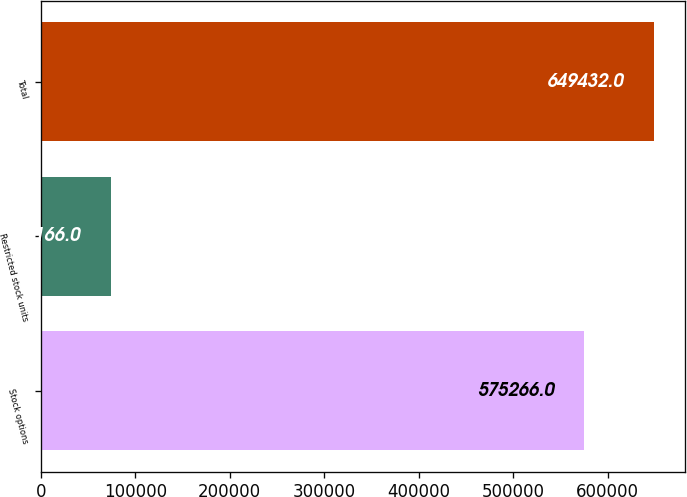Convert chart to OTSL. <chart><loc_0><loc_0><loc_500><loc_500><bar_chart><fcel>Stock options<fcel>Restricted stock units<fcel>Total<nl><fcel>575266<fcel>74166<fcel>649432<nl></chart> 